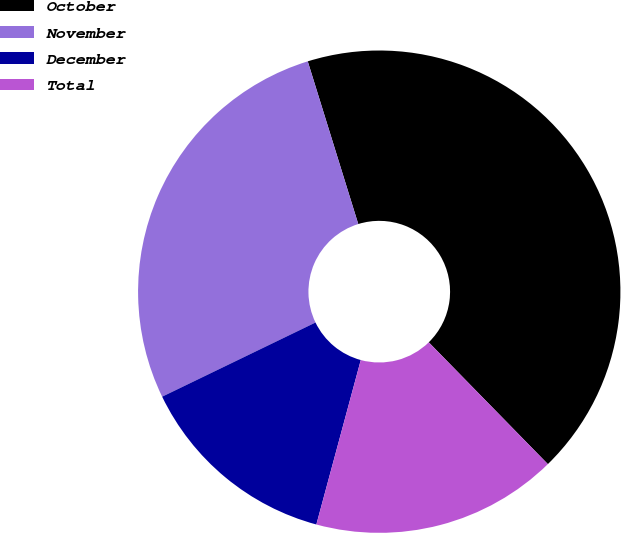Convert chart. <chart><loc_0><loc_0><loc_500><loc_500><pie_chart><fcel>October<fcel>November<fcel>December<fcel>Total<nl><fcel>42.47%<fcel>27.38%<fcel>13.63%<fcel>16.52%<nl></chart> 